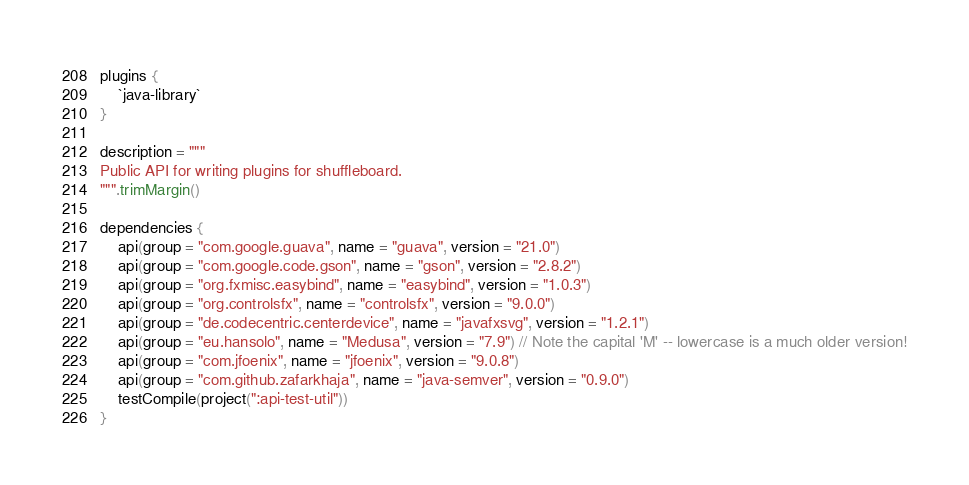Convert code to text. <code><loc_0><loc_0><loc_500><loc_500><_Kotlin_>plugins {
    `java-library`
}

description = """
Public API for writing plugins for shuffleboard.
""".trimMargin()

dependencies {
    api(group = "com.google.guava", name = "guava", version = "21.0")
    api(group = "com.google.code.gson", name = "gson", version = "2.8.2")
    api(group = "org.fxmisc.easybind", name = "easybind", version = "1.0.3")
    api(group = "org.controlsfx", name = "controlsfx", version = "9.0.0")
    api(group = "de.codecentric.centerdevice", name = "javafxsvg", version = "1.2.1")
    api(group = "eu.hansolo", name = "Medusa", version = "7.9") // Note the capital 'M' -- lowercase is a much older version!
    api(group = "com.jfoenix", name = "jfoenix", version = "9.0.8")
    api(group = "com.github.zafarkhaja", name = "java-semver", version = "0.9.0")
    testCompile(project(":api-test-util"))
}
</code> 